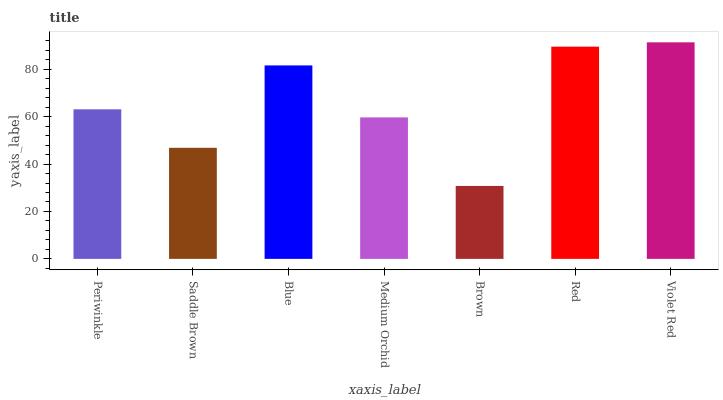Is Brown the minimum?
Answer yes or no. Yes. Is Violet Red the maximum?
Answer yes or no. Yes. Is Saddle Brown the minimum?
Answer yes or no. No. Is Saddle Brown the maximum?
Answer yes or no. No. Is Periwinkle greater than Saddle Brown?
Answer yes or no. Yes. Is Saddle Brown less than Periwinkle?
Answer yes or no. Yes. Is Saddle Brown greater than Periwinkle?
Answer yes or no. No. Is Periwinkle less than Saddle Brown?
Answer yes or no. No. Is Periwinkle the high median?
Answer yes or no. Yes. Is Periwinkle the low median?
Answer yes or no. Yes. Is Brown the high median?
Answer yes or no. No. Is Red the low median?
Answer yes or no. No. 